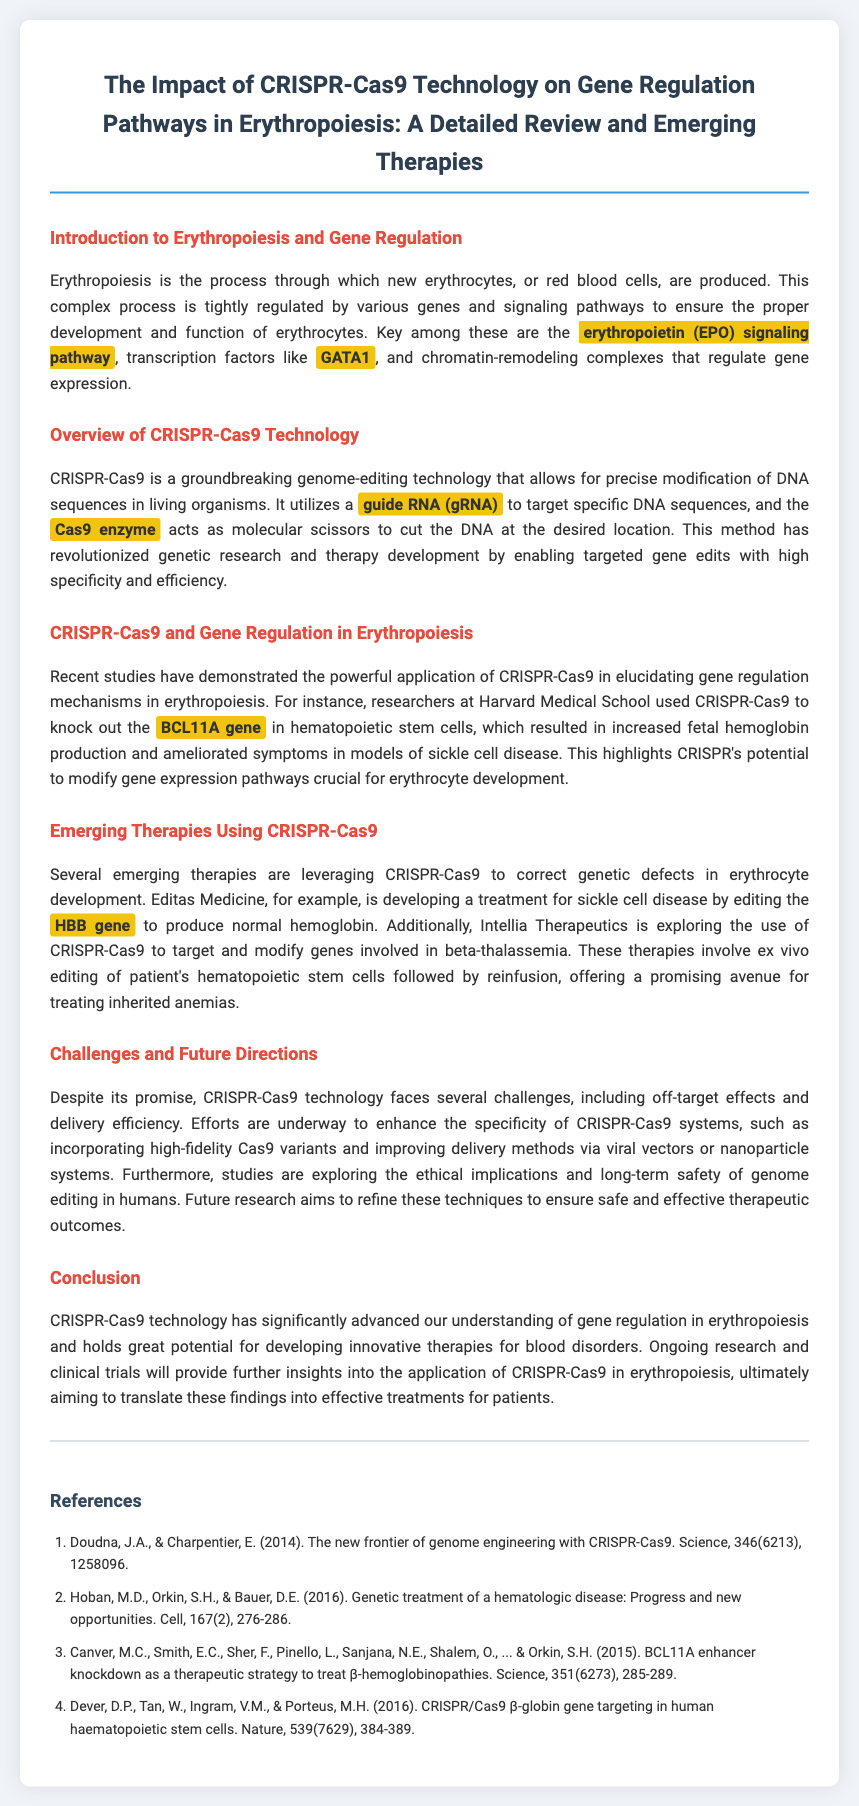What is the focus of this review? The review focuses on the impact of CRISPR-Cas9 technology on gene regulation pathways in erythropoiesis.
Answer: CRISPR-Cas9 technology on gene regulation pathways in erythropoiesis What gene was knocked out in studies at Harvard Medical School? The document mentions the BCL11A gene was knocked out.
Answer: BCL11A What is the role of erythropoietin in erythropoiesis? The document states that erythropoietin (EPO) is part of the signaling pathway regulating erythrocyte development.
Answer: Regulating erythrocyte development Which company is developing a treatment for sickle cell disease using CRISPR-Cas9? Editas Medicine is the company mentioned developing a treatment for sickle cell disease.
Answer: Editas Medicine What is a major challenge associated with CRISPR-Cas9 technology? Off-target effects are highlighted as a challenge in the document.
Answer: Off-target effects What technology is used for targeted gene edits? The document specifies CRISPR-Cas9 as the technology used.
Answer: CRISPR-Cas9 Which transcription factor is crucial for erythrocyte development? GATA1 is the transcription factor noted in the document.
Answer: GATA1 What is the aim of future research in CRISPR-Cas9 as mentioned? Future research aims to refine techniques for safe and effective therapeutic outcomes.
Answer: Refine techniques for safe and effective therapeutic outcomes 